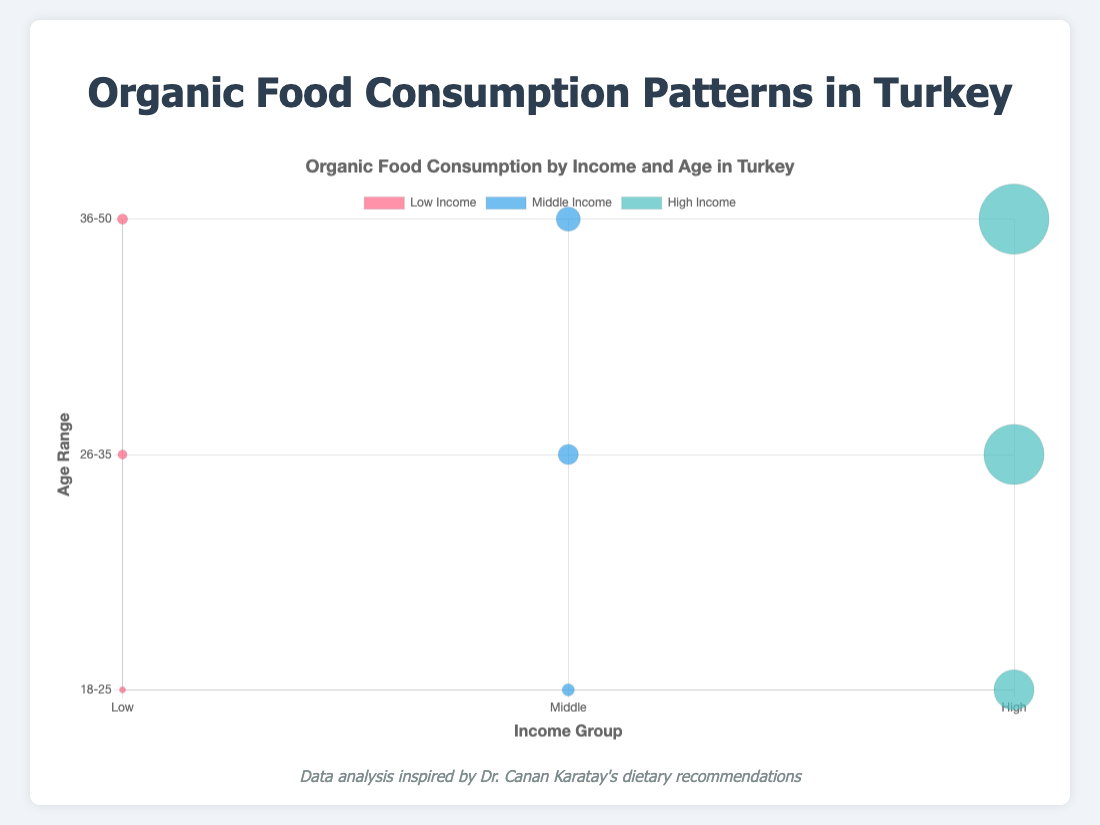What is the title of the chart? The title of the chart is displayed at the top, above the chart itself.
Answer: Organic Food Consumption by Income and Age in Turkey How many income groups are represented in the chart? The x-axis uses different tick marks to represent the income groups.
Answer: 3 (Low, Middle, High) Which age group and income group combination has the highest percentage of organic food consumption? By inspecting the bubble colors, the deepest color represents the highest percentage. The largest and darkest bubble is in the High Income group for the 36-50 age range.
Answer: High Income (36-50) What is the average spending for the 26-35 age range in the Middle Income group? Locate the bubble representing the Middle Income group at the 26-35 age range. The size of the bubble represents average spending.
Answer: 100 TL Compare the average spending on organic food between the Low Income group aged 26-35 and the High Income group aged 18-25. Identify each bubble and compare their sizes, representing average spending.
Answer: Low Income (26-35): 45 TL, High Income (18-25): 200 TL. The High Income group spends more Which income group has the largest bubble for the 18-25 age range? Focus on the bubbles at the 18-25 age range on the y-axis and compare their sizes by group.
Answer: High Income How much more do the High Income group aged 36-50 spend on organic food compared to the Middle Income group in the same range? Compare the average spendings represented by the bubbles in the 36-50 age range for High and Middle Income groups. Subtract the smaller average spending from the larger one.
Answer: 350 TL - 120 TL = 230 TL What is the difference in organic food consumption percentage between Low Income age 18-25 and High Income age 26-35? Check the color gradients for these bubbles. The Low Income group in the 18-25 range has a 5% consumption rate, and the High Income group in the 26-35 range has a 50% consumption rate. Subtract the smaller percentage from the larger one.
Answer: 50% - 5% = 45% In the Middle Income group, which age range has the highest organic food consumption percentage? Compare the color intensities of the bubbles within the Middle Income group across all age ranges.
Answer: 36-50 age range Is there an age range where the average spending on organic food is less than 50 TL? If yes, which income group does it belong to? Compare bubble sizes across all age ranges and income groups to find any bubbles representing average spendings below 50 TL.
Answer: Yes, Low Income (18-25 and 26-35) 